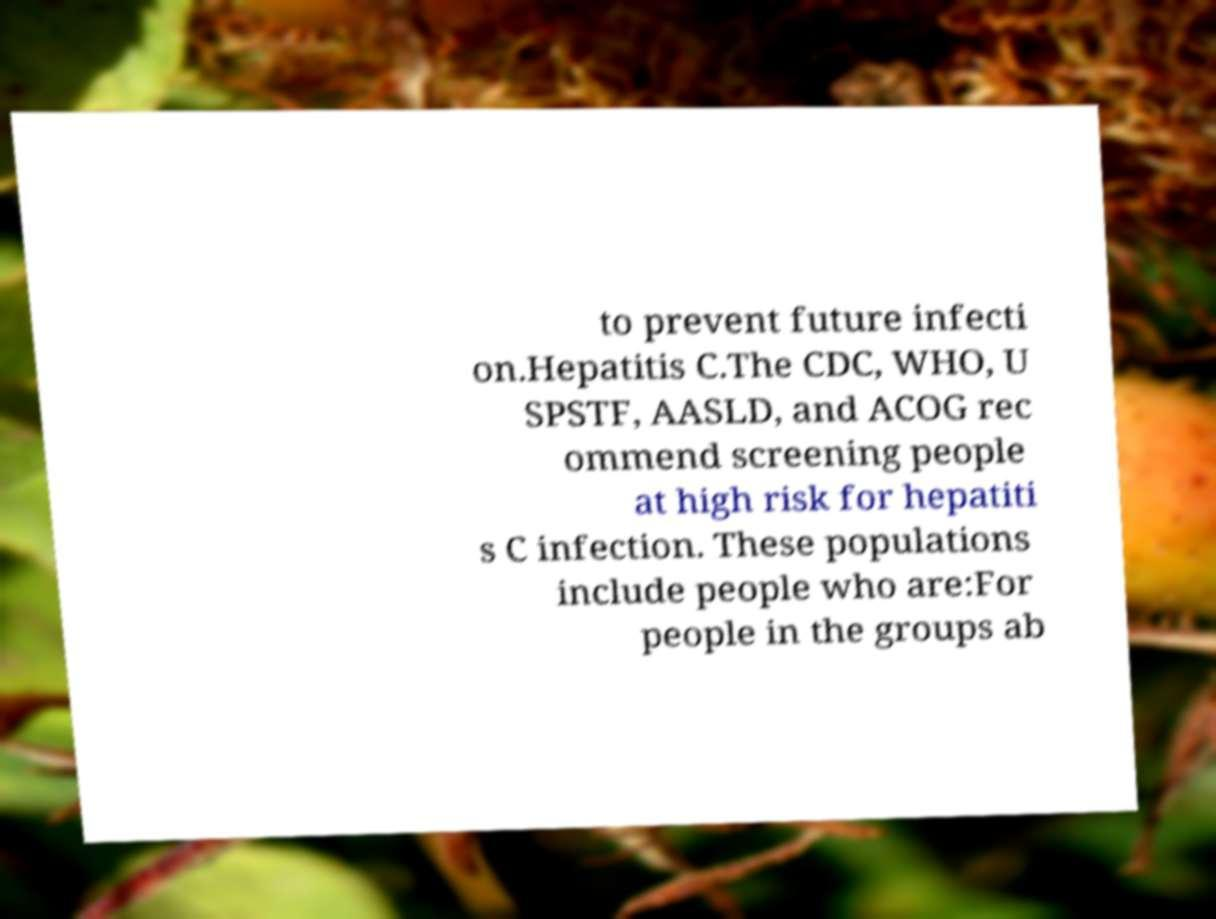What messages or text are displayed in this image? I need them in a readable, typed format. to prevent future infecti on.Hepatitis C.The CDC, WHO, U SPSTF, AASLD, and ACOG rec ommend screening people at high risk for hepatiti s C infection. These populations include people who are:For people in the groups ab 